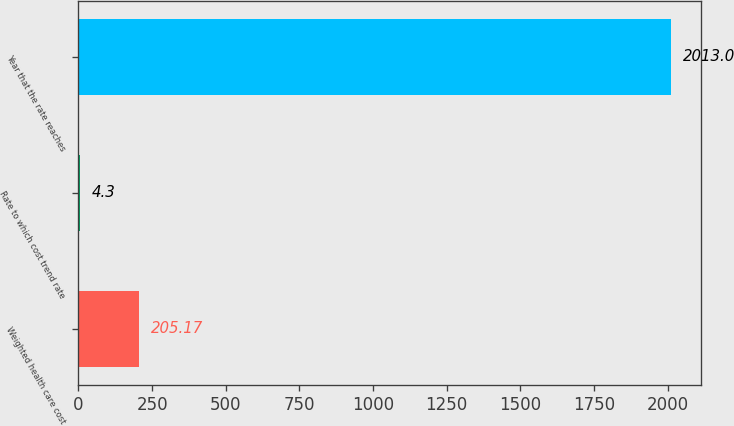Convert chart to OTSL. <chart><loc_0><loc_0><loc_500><loc_500><bar_chart><fcel>Weighted health care cost<fcel>Rate to which cost trend rate<fcel>Year that the rate reaches<nl><fcel>205.17<fcel>4.3<fcel>2013<nl></chart> 